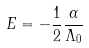Convert formula to latex. <formula><loc_0><loc_0><loc_500><loc_500>E = - \frac { 1 } { 2 } \frac { \alpha } { \Lambda _ { 0 } }</formula> 